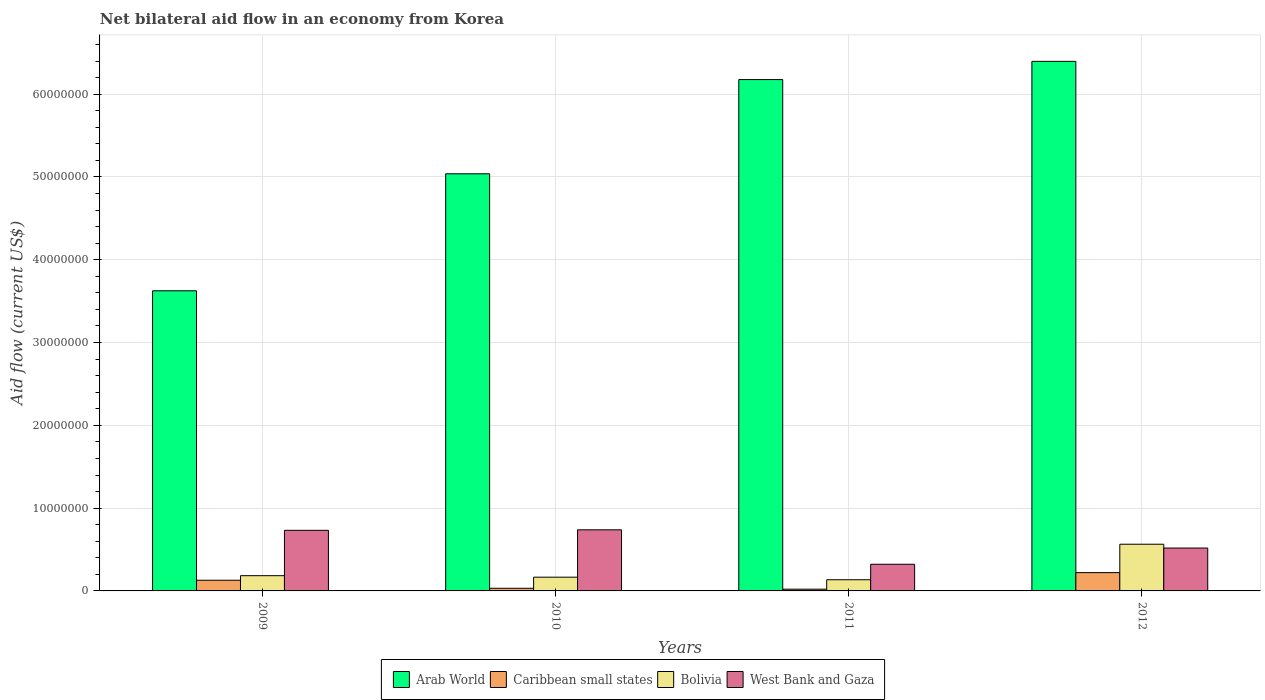How many different coloured bars are there?
Your answer should be compact. 4. How many groups of bars are there?
Ensure brevity in your answer.  4. How many bars are there on the 2nd tick from the left?
Your answer should be very brief. 4. How many bars are there on the 1st tick from the right?
Your answer should be very brief. 4. Across all years, what is the maximum net bilateral aid flow in Caribbean small states?
Your response must be concise. 2.21e+06. Across all years, what is the minimum net bilateral aid flow in Bolivia?
Your answer should be very brief. 1.35e+06. In which year was the net bilateral aid flow in West Bank and Gaza maximum?
Keep it short and to the point. 2010. What is the total net bilateral aid flow in Bolivia in the graph?
Give a very brief answer. 1.05e+07. What is the difference between the net bilateral aid flow in Bolivia in 2011 and that in 2012?
Your answer should be very brief. -4.29e+06. What is the difference between the net bilateral aid flow in West Bank and Gaza in 2011 and the net bilateral aid flow in Caribbean small states in 2012?
Your answer should be compact. 1.01e+06. What is the average net bilateral aid flow in West Bank and Gaza per year?
Provide a succinct answer. 5.78e+06. In the year 2011, what is the difference between the net bilateral aid flow in Bolivia and net bilateral aid flow in Arab World?
Your response must be concise. -6.04e+07. What is the ratio of the net bilateral aid flow in Arab World in 2010 to that in 2011?
Make the answer very short. 0.82. Is the net bilateral aid flow in Arab World in 2009 less than that in 2012?
Give a very brief answer. Yes. Is the difference between the net bilateral aid flow in Bolivia in 2010 and 2012 greater than the difference between the net bilateral aid flow in Arab World in 2010 and 2012?
Offer a terse response. Yes. What is the difference between the highest and the second highest net bilateral aid flow in Bolivia?
Your answer should be very brief. 3.80e+06. What is the difference between the highest and the lowest net bilateral aid flow in Arab World?
Provide a short and direct response. 2.77e+07. Is the sum of the net bilateral aid flow in Bolivia in 2009 and 2011 greater than the maximum net bilateral aid flow in West Bank and Gaza across all years?
Provide a succinct answer. No. Is it the case that in every year, the sum of the net bilateral aid flow in Caribbean small states and net bilateral aid flow in West Bank and Gaza is greater than the sum of net bilateral aid flow in Arab World and net bilateral aid flow in Bolivia?
Your answer should be compact. No. What does the 4th bar from the left in 2012 represents?
Provide a succinct answer. West Bank and Gaza. What does the 3rd bar from the right in 2010 represents?
Provide a short and direct response. Caribbean small states. Are all the bars in the graph horizontal?
Your answer should be compact. No. What is the difference between two consecutive major ticks on the Y-axis?
Provide a succinct answer. 1.00e+07. Are the values on the major ticks of Y-axis written in scientific E-notation?
Offer a very short reply. No. Does the graph contain any zero values?
Offer a terse response. No. Does the graph contain grids?
Your answer should be very brief. Yes. How many legend labels are there?
Provide a short and direct response. 4. What is the title of the graph?
Your answer should be very brief. Net bilateral aid flow in an economy from Korea. What is the Aid flow (current US$) in Arab World in 2009?
Your answer should be compact. 3.62e+07. What is the Aid flow (current US$) in Caribbean small states in 2009?
Your answer should be compact. 1.29e+06. What is the Aid flow (current US$) in Bolivia in 2009?
Provide a succinct answer. 1.84e+06. What is the Aid flow (current US$) in West Bank and Gaza in 2009?
Keep it short and to the point. 7.32e+06. What is the Aid flow (current US$) of Arab World in 2010?
Provide a succinct answer. 5.04e+07. What is the Aid flow (current US$) of Bolivia in 2010?
Your answer should be compact. 1.66e+06. What is the Aid flow (current US$) in West Bank and Gaza in 2010?
Provide a short and direct response. 7.38e+06. What is the Aid flow (current US$) of Arab World in 2011?
Ensure brevity in your answer.  6.18e+07. What is the Aid flow (current US$) of Caribbean small states in 2011?
Give a very brief answer. 2.10e+05. What is the Aid flow (current US$) in Bolivia in 2011?
Offer a terse response. 1.35e+06. What is the Aid flow (current US$) in West Bank and Gaza in 2011?
Keep it short and to the point. 3.22e+06. What is the Aid flow (current US$) of Arab World in 2012?
Your answer should be very brief. 6.40e+07. What is the Aid flow (current US$) of Caribbean small states in 2012?
Give a very brief answer. 2.21e+06. What is the Aid flow (current US$) in Bolivia in 2012?
Provide a short and direct response. 5.64e+06. What is the Aid flow (current US$) in West Bank and Gaza in 2012?
Provide a short and direct response. 5.18e+06. Across all years, what is the maximum Aid flow (current US$) of Arab World?
Keep it short and to the point. 6.40e+07. Across all years, what is the maximum Aid flow (current US$) of Caribbean small states?
Your answer should be very brief. 2.21e+06. Across all years, what is the maximum Aid flow (current US$) in Bolivia?
Offer a terse response. 5.64e+06. Across all years, what is the maximum Aid flow (current US$) of West Bank and Gaza?
Keep it short and to the point. 7.38e+06. Across all years, what is the minimum Aid flow (current US$) of Arab World?
Ensure brevity in your answer.  3.62e+07. Across all years, what is the minimum Aid flow (current US$) of Caribbean small states?
Provide a succinct answer. 2.10e+05. Across all years, what is the minimum Aid flow (current US$) in Bolivia?
Keep it short and to the point. 1.35e+06. Across all years, what is the minimum Aid flow (current US$) in West Bank and Gaza?
Your answer should be very brief. 3.22e+06. What is the total Aid flow (current US$) in Arab World in the graph?
Keep it short and to the point. 2.12e+08. What is the total Aid flow (current US$) in Caribbean small states in the graph?
Keep it short and to the point. 4.03e+06. What is the total Aid flow (current US$) of Bolivia in the graph?
Give a very brief answer. 1.05e+07. What is the total Aid flow (current US$) in West Bank and Gaza in the graph?
Make the answer very short. 2.31e+07. What is the difference between the Aid flow (current US$) of Arab World in 2009 and that in 2010?
Ensure brevity in your answer.  -1.41e+07. What is the difference between the Aid flow (current US$) in Caribbean small states in 2009 and that in 2010?
Your answer should be very brief. 9.70e+05. What is the difference between the Aid flow (current US$) in West Bank and Gaza in 2009 and that in 2010?
Offer a very short reply. -6.00e+04. What is the difference between the Aid flow (current US$) in Arab World in 2009 and that in 2011?
Provide a succinct answer. -2.55e+07. What is the difference between the Aid flow (current US$) of Caribbean small states in 2009 and that in 2011?
Offer a terse response. 1.08e+06. What is the difference between the Aid flow (current US$) of Bolivia in 2009 and that in 2011?
Offer a terse response. 4.90e+05. What is the difference between the Aid flow (current US$) in West Bank and Gaza in 2009 and that in 2011?
Make the answer very short. 4.10e+06. What is the difference between the Aid flow (current US$) of Arab World in 2009 and that in 2012?
Your response must be concise. -2.77e+07. What is the difference between the Aid flow (current US$) in Caribbean small states in 2009 and that in 2012?
Your response must be concise. -9.20e+05. What is the difference between the Aid flow (current US$) in Bolivia in 2009 and that in 2012?
Give a very brief answer. -3.80e+06. What is the difference between the Aid flow (current US$) of West Bank and Gaza in 2009 and that in 2012?
Provide a succinct answer. 2.14e+06. What is the difference between the Aid flow (current US$) in Arab World in 2010 and that in 2011?
Provide a succinct answer. -1.14e+07. What is the difference between the Aid flow (current US$) of Bolivia in 2010 and that in 2011?
Provide a succinct answer. 3.10e+05. What is the difference between the Aid flow (current US$) of West Bank and Gaza in 2010 and that in 2011?
Offer a very short reply. 4.16e+06. What is the difference between the Aid flow (current US$) of Arab World in 2010 and that in 2012?
Make the answer very short. -1.36e+07. What is the difference between the Aid flow (current US$) of Caribbean small states in 2010 and that in 2012?
Offer a terse response. -1.89e+06. What is the difference between the Aid flow (current US$) in Bolivia in 2010 and that in 2012?
Give a very brief answer. -3.98e+06. What is the difference between the Aid flow (current US$) in West Bank and Gaza in 2010 and that in 2012?
Offer a very short reply. 2.20e+06. What is the difference between the Aid flow (current US$) in Arab World in 2011 and that in 2012?
Your answer should be compact. -2.20e+06. What is the difference between the Aid flow (current US$) of Bolivia in 2011 and that in 2012?
Your answer should be compact. -4.29e+06. What is the difference between the Aid flow (current US$) in West Bank and Gaza in 2011 and that in 2012?
Offer a very short reply. -1.96e+06. What is the difference between the Aid flow (current US$) of Arab World in 2009 and the Aid flow (current US$) of Caribbean small states in 2010?
Your response must be concise. 3.59e+07. What is the difference between the Aid flow (current US$) in Arab World in 2009 and the Aid flow (current US$) in Bolivia in 2010?
Your response must be concise. 3.46e+07. What is the difference between the Aid flow (current US$) in Arab World in 2009 and the Aid flow (current US$) in West Bank and Gaza in 2010?
Give a very brief answer. 2.89e+07. What is the difference between the Aid flow (current US$) of Caribbean small states in 2009 and the Aid flow (current US$) of Bolivia in 2010?
Offer a terse response. -3.70e+05. What is the difference between the Aid flow (current US$) in Caribbean small states in 2009 and the Aid flow (current US$) in West Bank and Gaza in 2010?
Give a very brief answer. -6.09e+06. What is the difference between the Aid flow (current US$) in Bolivia in 2009 and the Aid flow (current US$) in West Bank and Gaza in 2010?
Your response must be concise. -5.54e+06. What is the difference between the Aid flow (current US$) of Arab World in 2009 and the Aid flow (current US$) of Caribbean small states in 2011?
Offer a very short reply. 3.60e+07. What is the difference between the Aid flow (current US$) of Arab World in 2009 and the Aid flow (current US$) of Bolivia in 2011?
Ensure brevity in your answer.  3.49e+07. What is the difference between the Aid flow (current US$) in Arab World in 2009 and the Aid flow (current US$) in West Bank and Gaza in 2011?
Give a very brief answer. 3.30e+07. What is the difference between the Aid flow (current US$) of Caribbean small states in 2009 and the Aid flow (current US$) of West Bank and Gaza in 2011?
Ensure brevity in your answer.  -1.93e+06. What is the difference between the Aid flow (current US$) in Bolivia in 2009 and the Aid flow (current US$) in West Bank and Gaza in 2011?
Offer a terse response. -1.38e+06. What is the difference between the Aid flow (current US$) in Arab World in 2009 and the Aid flow (current US$) in Caribbean small states in 2012?
Offer a very short reply. 3.40e+07. What is the difference between the Aid flow (current US$) of Arab World in 2009 and the Aid flow (current US$) of Bolivia in 2012?
Make the answer very short. 3.06e+07. What is the difference between the Aid flow (current US$) of Arab World in 2009 and the Aid flow (current US$) of West Bank and Gaza in 2012?
Ensure brevity in your answer.  3.11e+07. What is the difference between the Aid flow (current US$) in Caribbean small states in 2009 and the Aid flow (current US$) in Bolivia in 2012?
Provide a succinct answer. -4.35e+06. What is the difference between the Aid flow (current US$) of Caribbean small states in 2009 and the Aid flow (current US$) of West Bank and Gaza in 2012?
Ensure brevity in your answer.  -3.89e+06. What is the difference between the Aid flow (current US$) of Bolivia in 2009 and the Aid flow (current US$) of West Bank and Gaza in 2012?
Offer a terse response. -3.34e+06. What is the difference between the Aid flow (current US$) in Arab World in 2010 and the Aid flow (current US$) in Caribbean small states in 2011?
Offer a very short reply. 5.02e+07. What is the difference between the Aid flow (current US$) of Arab World in 2010 and the Aid flow (current US$) of Bolivia in 2011?
Provide a short and direct response. 4.90e+07. What is the difference between the Aid flow (current US$) of Arab World in 2010 and the Aid flow (current US$) of West Bank and Gaza in 2011?
Offer a terse response. 4.72e+07. What is the difference between the Aid flow (current US$) of Caribbean small states in 2010 and the Aid flow (current US$) of Bolivia in 2011?
Provide a short and direct response. -1.03e+06. What is the difference between the Aid flow (current US$) of Caribbean small states in 2010 and the Aid flow (current US$) of West Bank and Gaza in 2011?
Offer a very short reply. -2.90e+06. What is the difference between the Aid flow (current US$) in Bolivia in 2010 and the Aid flow (current US$) in West Bank and Gaza in 2011?
Provide a short and direct response. -1.56e+06. What is the difference between the Aid flow (current US$) in Arab World in 2010 and the Aid flow (current US$) in Caribbean small states in 2012?
Offer a very short reply. 4.82e+07. What is the difference between the Aid flow (current US$) in Arab World in 2010 and the Aid flow (current US$) in Bolivia in 2012?
Offer a terse response. 4.47e+07. What is the difference between the Aid flow (current US$) in Arab World in 2010 and the Aid flow (current US$) in West Bank and Gaza in 2012?
Make the answer very short. 4.52e+07. What is the difference between the Aid flow (current US$) in Caribbean small states in 2010 and the Aid flow (current US$) in Bolivia in 2012?
Offer a very short reply. -5.32e+06. What is the difference between the Aid flow (current US$) in Caribbean small states in 2010 and the Aid flow (current US$) in West Bank and Gaza in 2012?
Give a very brief answer. -4.86e+06. What is the difference between the Aid flow (current US$) in Bolivia in 2010 and the Aid flow (current US$) in West Bank and Gaza in 2012?
Offer a terse response. -3.52e+06. What is the difference between the Aid flow (current US$) in Arab World in 2011 and the Aid flow (current US$) in Caribbean small states in 2012?
Offer a very short reply. 5.96e+07. What is the difference between the Aid flow (current US$) of Arab World in 2011 and the Aid flow (current US$) of Bolivia in 2012?
Your answer should be very brief. 5.61e+07. What is the difference between the Aid flow (current US$) in Arab World in 2011 and the Aid flow (current US$) in West Bank and Gaza in 2012?
Your answer should be very brief. 5.66e+07. What is the difference between the Aid flow (current US$) in Caribbean small states in 2011 and the Aid flow (current US$) in Bolivia in 2012?
Keep it short and to the point. -5.43e+06. What is the difference between the Aid flow (current US$) of Caribbean small states in 2011 and the Aid flow (current US$) of West Bank and Gaza in 2012?
Your response must be concise. -4.97e+06. What is the difference between the Aid flow (current US$) in Bolivia in 2011 and the Aid flow (current US$) in West Bank and Gaza in 2012?
Give a very brief answer. -3.83e+06. What is the average Aid flow (current US$) in Arab World per year?
Keep it short and to the point. 5.31e+07. What is the average Aid flow (current US$) of Caribbean small states per year?
Offer a terse response. 1.01e+06. What is the average Aid flow (current US$) of Bolivia per year?
Offer a very short reply. 2.62e+06. What is the average Aid flow (current US$) of West Bank and Gaza per year?
Ensure brevity in your answer.  5.78e+06. In the year 2009, what is the difference between the Aid flow (current US$) in Arab World and Aid flow (current US$) in Caribbean small states?
Your answer should be compact. 3.50e+07. In the year 2009, what is the difference between the Aid flow (current US$) in Arab World and Aid flow (current US$) in Bolivia?
Make the answer very short. 3.44e+07. In the year 2009, what is the difference between the Aid flow (current US$) in Arab World and Aid flow (current US$) in West Bank and Gaza?
Provide a short and direct response. 2.89e+07. In the year 2009, what is the difference between the Aid flow (current US$) in Caribbean small states and Aid flow (current US$) in Bolivia?
Keep it short and to the point. -5.50e+05. In the year 2009, what is the difference between the Aid flow (current US$) in Caribbean small states and Aid flow (current US$) in West Bank and Gaza?
Provide a short and direct response. -6.03e+06. In the year 2009, what is the difference between the Aid flow (current US$) in Bolivia and Aid flow (current US$) in West Bank and Gaza?
Provide a succinct answer. -5.48e+06. In the year 2010, what is the difference between the Aid flow (current US$) in Arab World and Aid flow (current US$) in Caribbean small states?
Your answer should be compact. 5.01e+07. In the year 2010, what is the difference between the Aid flow (current US$) in Arab World and Aid flow (current US$) in Bolivia?
Provide a short and direct response. 4.87e+07. In the year 2010, what is the difference between the Aid flow (current US$) of Arab World and Aid flow (current US$) of West Bank and Gaza?
Offer a very short reply. 4.30e+07. In the year 2010, what is the difference between the Aid flow (current US$) in Caribbean small states and Aid flow (current US$) in Bolivia?
Your answer should be very brief. -1.34e+06. In the year 2010, what is the difference between the Aid flow (current US$) in Caribbean small states and Aid flow (current US$) in West Bank and Gaza?
Provide a succinct answer. -7.06e+06. In the year 2010, what is the difference between the Aid flow (current US$) of Bolivia and Aid flow (current US$) of West Bank and Gaza?
Make the answer very short. -5.72e+06. In the year 2011, what is the difference between the Aid flow (current US$) of Arab World and Aid flow (current US$) of Caribbean small states?
Your answer should be compact. 6.16e+07. In the year 2011, what is the difference between the Aid flow (current US$) in Arab World and Aid flow (current US$) in Bolivia?
Give a very brief answer. 6.04e+07. In the year 2011, what is the difference between the Aid flow (current US$) of Arab World and Aid flow (current US$) of West Bank and Gaza?
Your response must be concise. 5.85e+07. In the year 2011, what is the difference between the Aid flow (current US$) in Caribbean small states and Aid flow (current US$) in Bolivia?
Provide a short and direct response. -1.14e+06. In the year 2011, what is the difference between the Aid flow (current US$) of Caribbean small states and Aid flow (current US$) of West Bank and Gaza?
Your answer should be very brief. -3.01e+06. In the year 2011, what is the difference between the Aid flow (current US$) of Bolivia and Aid flow (current US$) of West Bank and Gaza?
Offer a terse response. -1.87e+06. In the year 2012, what is the difference between the Aid flow (current US$) in Arab World and Aid flow (current US$) in Caribbean small states?
Provide a short and direct response. 6.18e+07. In the year 2012, what is the difference between the Aid flow (current US$) of Arab World and Aid flow (current US$) of Bolivia?
Keep it short and to the point. 5.83e+07. In the year 2012, what is the difference between the Aid flow (current US$) of Arab World and Aid flow (current US$) of West Bank and Gaza?
Provide a succinct answer. 5.88e+07. In the year 2012, what is the difference between the Aid flow (current US$) of Caribbean small states and Aid flow (current US$) of Bolivia?
Ensure brevity in your answer.  -3.43e+06. In the year 2012, what is the difference between the Aid flow (current US$) of Caribbean small states and Aid flow (current US$) of West Bank and Gaza?
Ensure brevity in your answer.  -2.97e+06. In the year 2012, what is the difference between the Aid flow (current US$) of Bolivia and Aid flow (current US$) of West Bank and Gaza?
Give a very brief answer. 4.60e+05. What is the ratio of the Aid flow (current US$) of Arab World in 2009 to that in 2010?
Offer a terse response. 0.72. What is the ratio of the Aid flow (current US$) of Caribbean small states in 2009 to that in 2010?
Provide a succinct answer. 4.03. What is the ratio of the Aid flow (current US$) in Bolivia in 2009 to that in 2010?
Offer a terse response. 1.11. What is the ratio of the Aid flow (current US$) in Arab World in 2009 to that in 2011?
Provide a succinct answer. 0.59. What is the ratio of the Aid flow (current US$) in Caribbean small states in 2009 to that in 2011?
Provide a short and direct response. 6.14. What is the ratio of the Aid flow (current US$) of Bolivia in 2009 to that in 2011?
Keep it short and to the point. 1.36. What is the ratio of the Aid flow (current US$) of West Bank and Gaza in 2009 to that in 2011?
Make the answer very short. 2.27. What is the ratio of the Aid flow (current US$) of Arab World in 2009 to that in 2012?
Offer a terse response. 0.57. What is the ratio of the Aid flow (current US$) of Caribbean small states in 2009 to that in 2012?
Provide a short and direct response. 0.58. What is the ratio of the Aid flow (current US$) in Bolivia in 2009 to that in 2012?
Provide a short and direct response. 0.33. What is the ratio of the Aid flow (current US$) of West Bank and Gaza in 2009 to that in 2012?
Offer a very short reply. 1.41. What is the ratio of the Aid flow (current US$) in Arab World in 2010 to that in 2011?
Keep it short and to the point. 0.82. What is the ratio of the Aid flow (current US$) of Caribbean small states in 2010 to that in 2011?
Give a very brief answer. 1.52. What is the ratio of the Aid flow (current US$) in Bolivia in 2010 to that in 2011?
Ensure brevity in your answer.  1.23. What is the ratio of the Aid flow (current US$) in West Bank and Gaza in 2010 to that in 2011?
Provide a short and direct response. 2.29. What is the ratio of the Aid flow (current US$) of Arab World in 2010 to that in 2012?
Give a very brief answer. 0.79. What is the ratio of the Aid flow (current US$) in Caribbean small states in 2010 to that in 2012?
Give a very brief answer. 0.14. What is the ratio of the Aid flow (current US$) in Bolivia in 2010 to that in 2012?
Ensure brevity in your answer.  0.29. What is the ratio of the Aid flow (current US$) in West Bank and Gaza in 2010 to that in 2012?
Provide a succinct answer. 1.42. What is the ratio of the Aid flow (current US$) of Arab World in 2011 to that in 2012?
Provide a succinct answer. 0.97. What is the ratio of the Aid flow (current US$) in Caribbean small states in 2011 to that in 2012?
Your answer should be very brief. 0.1. What is the ratio of the Aid flow (current US$) in Bolivia in 2011 to that in 2012?
Offer a very short reply. 0.24. What is the ratio of the Aid flow (current US$) in West Bank and Gaza in 2011 to that in 2012?
Your answer should be very brief. 0.62. What is the difference between the highest and the second highest Aid flow (current US$) in Arab World?
Make the answer very short. 2.20e+06. What is the difference between the highest and the second highest Aid flow (current US$) of Caribbean small states?
Your response must be concise. 9.20e+05. What is the difference between the highest and the second highest Aid flow (current US$) in Bolivia?
Your answer should be compact. 3.80e+06. What is the difference between the highest and the second highest Aid flow (current US$) in West Bank and Gaza?
Ensure brevity in your answer.  6.00e+04. What is the difference between the highest and the lowest Aid flow (current US$) of Arab World?
Make the answer very short. 2.77e+07. What is the difference between the highest and the lowest Aid flow (current US$) of Bolivia?
Provide a succinct answer. 4.29e+06. What is the difference between the highest and the lowest Aid flow (current US$) in West Bank and Gaza?
Offer a very short reply. 4.16e+06. 